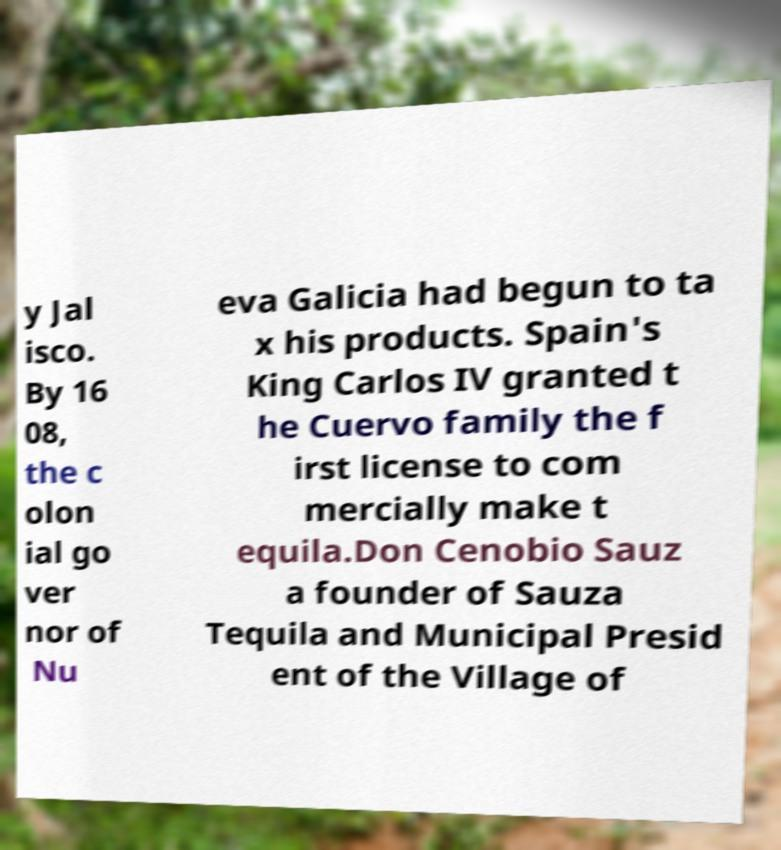Can you read and provide the text displayed in the image?This photo seems to have some interesting text. Can you extract and type it out for me? y Jal isco. By 16 08, the c olon ial go ver nor of Nu eva Galicia had begun to ta x his products. Spain's King Carlos IV granted t he Cuervo family the f irst license to com mercially make t equila.Don Cenobio Sauz a founder of Sauza Tequila and Municipal Presid ent of the Village of 